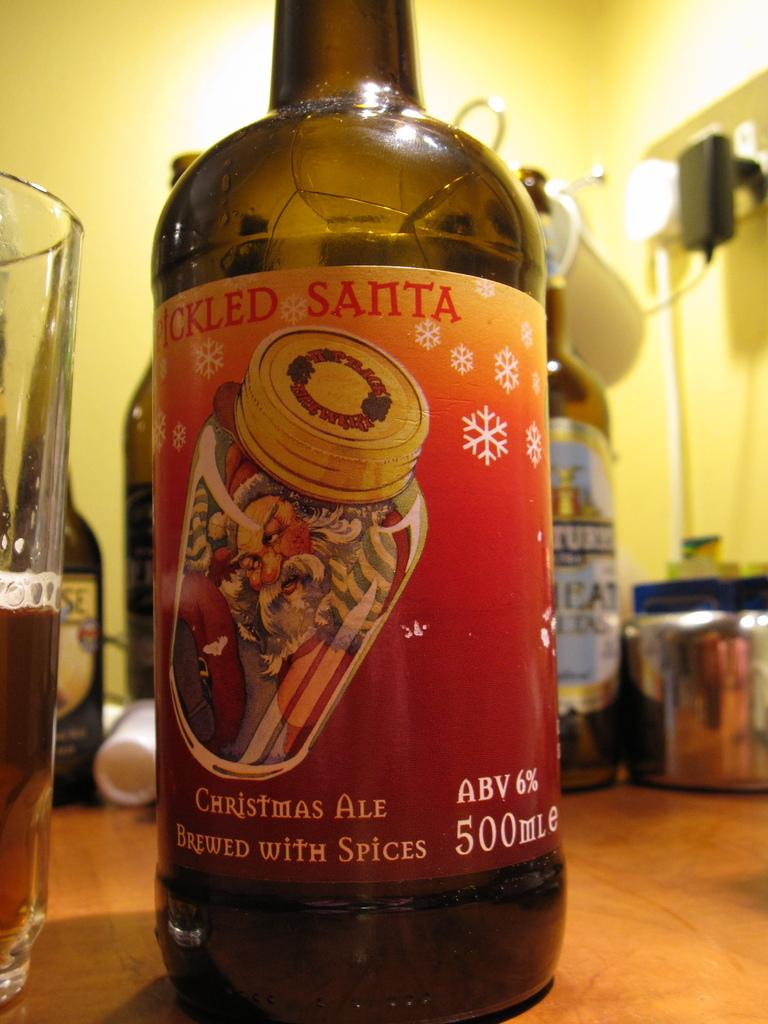<image>
Provide a brief description of the given image. a close up of Pickled Santa Christmas Ale Brewed with Spices 